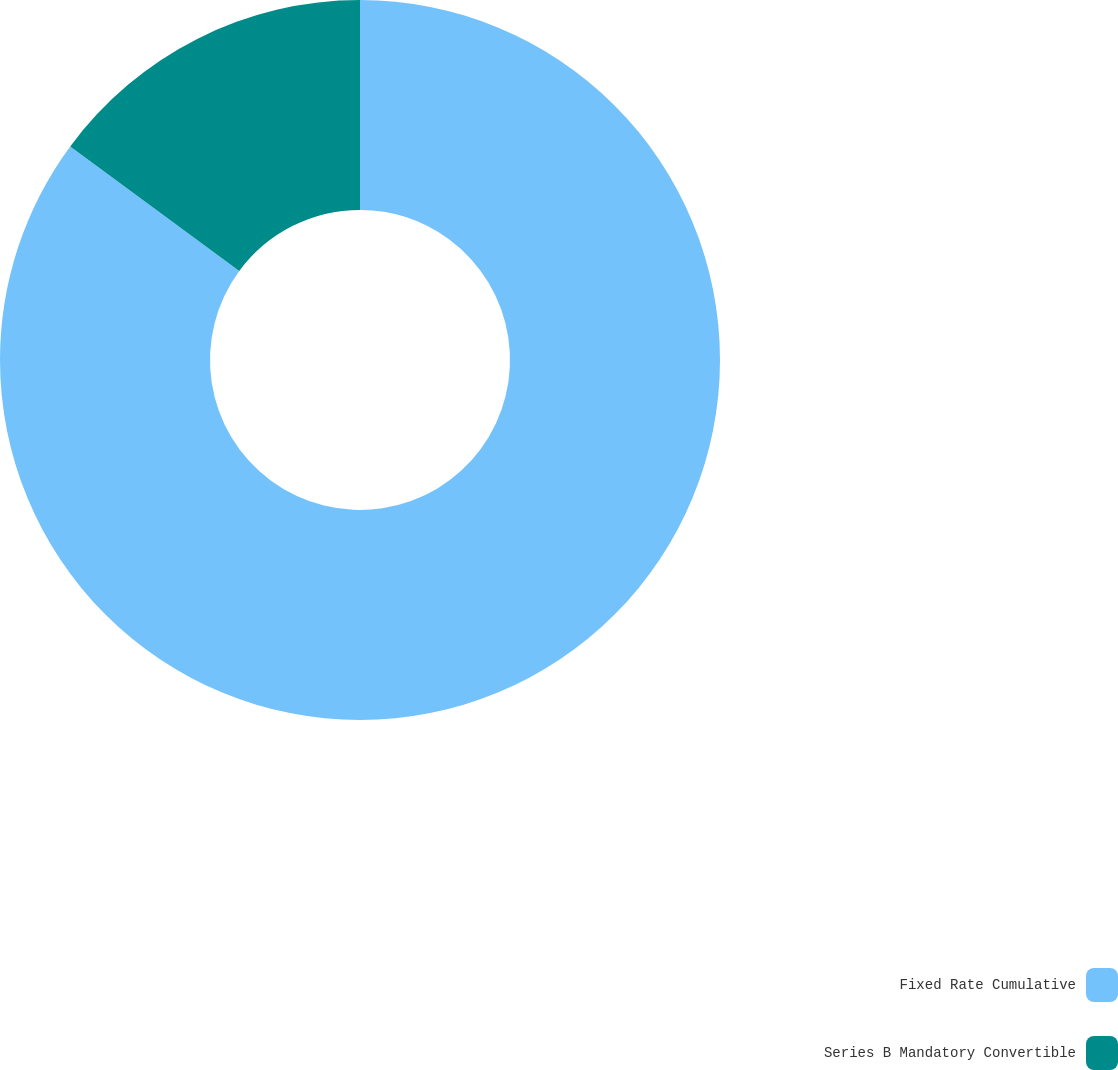<chart> <loc_0><loc_0><loc_500><loc_500><pie_chart><fcel>Fixed Rate Cumulative<fcel>Series B Mandatory Convertible<nl><fcel>85.11%<fcel>14.89%<nl></chart> 